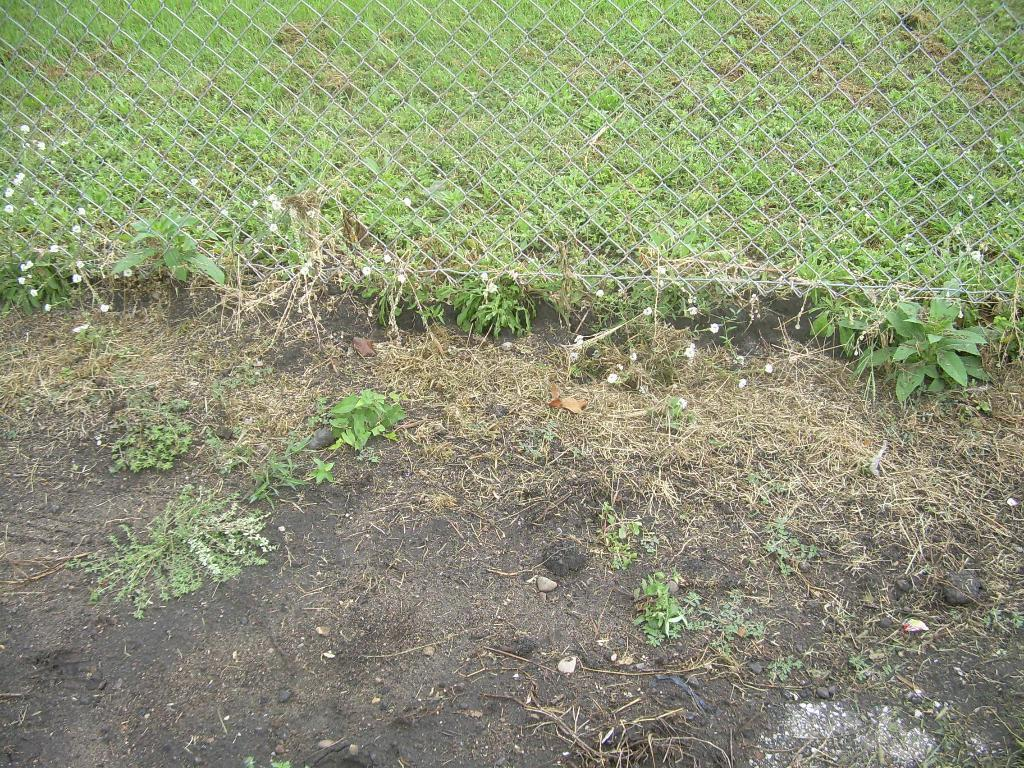What type of fence can be seen in the image? There is an iron fence in the image. What is visible behind the iron fence? Grass is visible behind the iron fence. What type of soil is present at the bottom of the image? Black soil is present at the bottom of the image. What type of vegetation can be seen in the image? Plants are visible in the image. What is the condition of the grass in the image? Dried grass is present in the image. Where is the book located in the image? There is no book present in the image. What type of animal can be seen interacting with the plants in the image? There is no animal present in the image; it only features plants, grass, and an iron fence. 